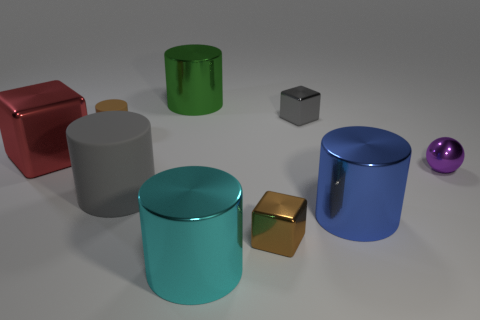Are there an equal number of big metal cylinders in front of the red metallic cube and big red blocks that are to the right of the small metal sphere?
Keep it short and to the point. No. Are there any small purple objects?
Your answer should be compact. Yes. There is a cyan metal thing that is the same shape as the brown matte thing; what is its size?
Ensure brevity in your answer.  Large. There is a shiny object that is on the left side of the large gray rubber cylinder; how big is it?
Offer a terse response. Large. Is the number of brown metal cubes that are to the left of the small cylinder greater than the number of tiny brown rubber things?
Your answer should be very brief. No. There is a purple object; what shape is it?
Offer a terse response. Sphere. There is a block on the left side of the cyan metallic thing; is it the same color as the small block behind the tiny brown cube?
Your answer should be very brief. No. Do the large cyan shiny object and the large rubber thing have the same shape?
Give a very brief answer. Yes. Is there any other thing that has the same shape as the green shiny thing?
Your response must be concise. Yes. Is the material of the small thing left of the large cyan object the same as the small purple object?
Give a very brief answer. No. 